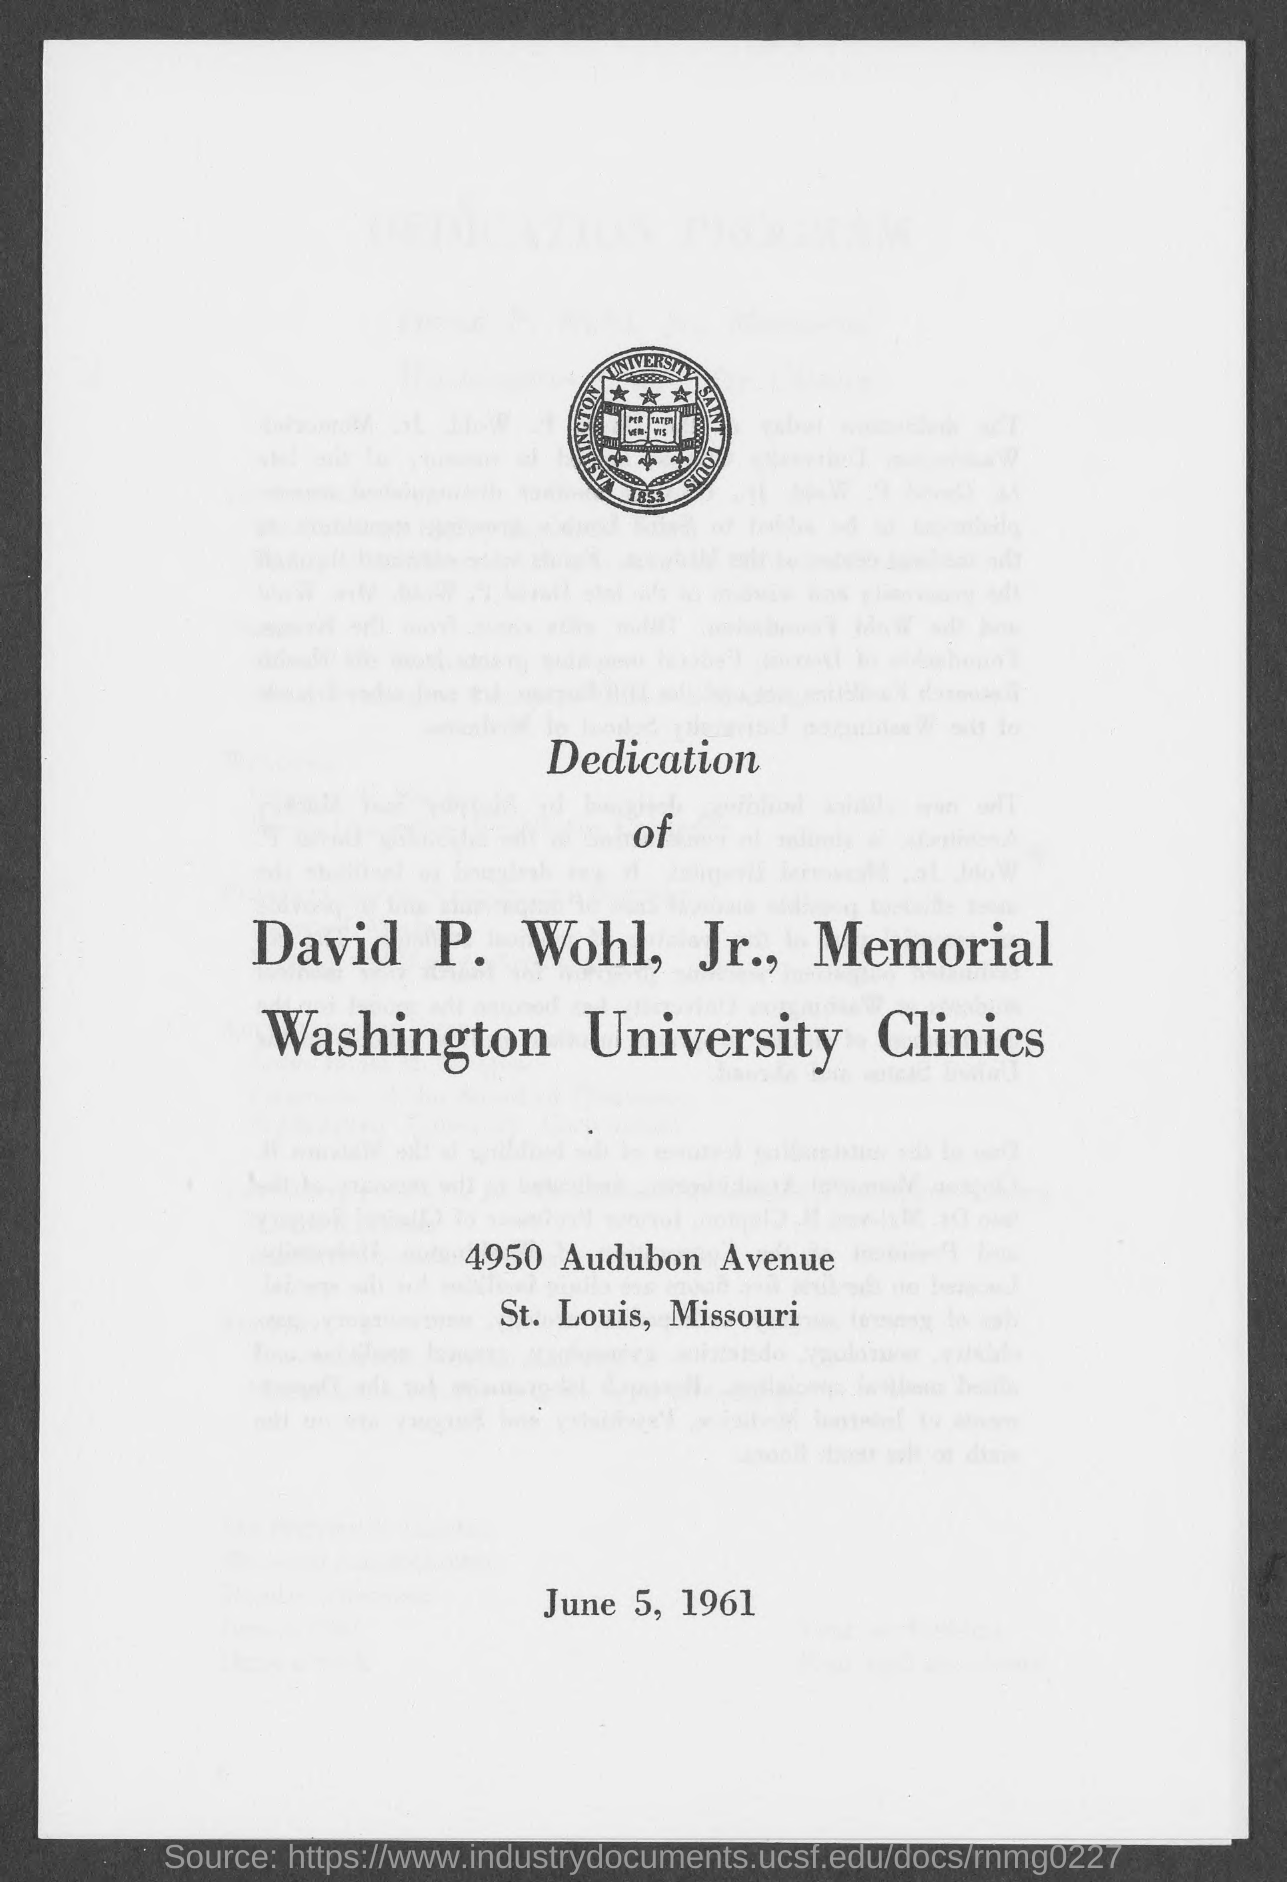What is the year in the logo?
Give a very brief answer. 1853. When did the copy printed?
Offer a very short reply. June 5, 1961. 